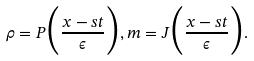Convert formula to latex. <formula><loc_0><loc_0><loc_500><loc_500>\rho = P \Big { ( } \frac { x - s t } { \epsilon } \Big { ) } , m = J \Big { ( } \frac { x - s t } { \epsilon } \Big { ) } .</formula> 